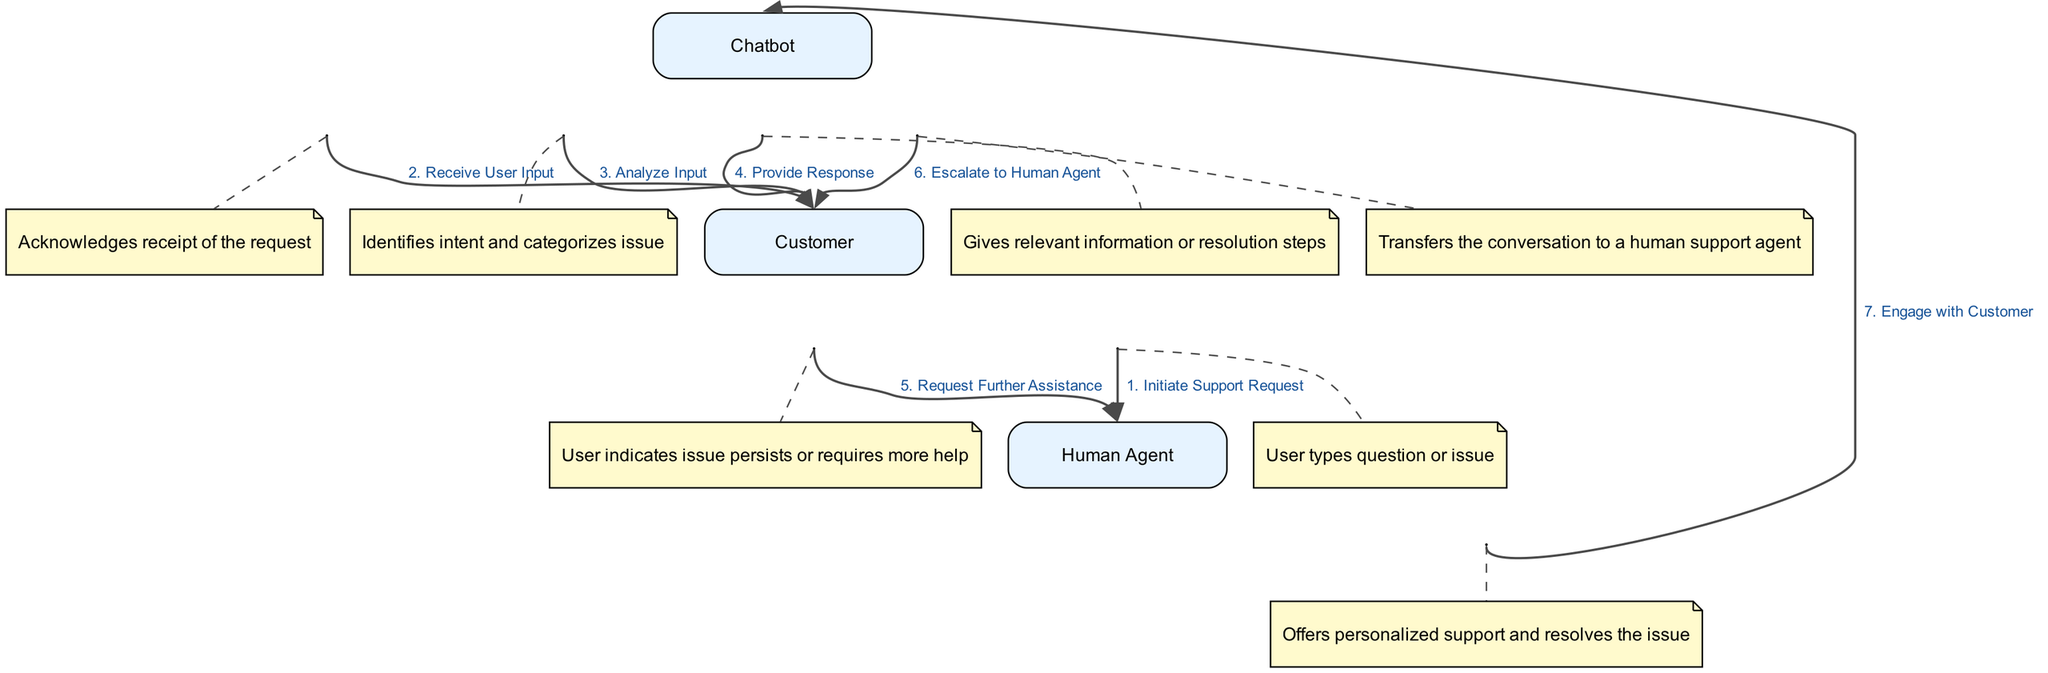What is the first action taken by the Customer? The diagram indicates that the first action taken by the Customer is to "Initiate Support Request." This is the very first element in the sequence outlining the process.
Answer: Initiate Support Request How many entities are represented in the diagram? There are three distinct entities in the diagram represented: Customer, Chatbot, and Human Agent. Each entity is shown as a separate box corresponding to their roles in the sequence.
Answer: Three What does the Chatbot do after receiving user input? After receiving the user input, the Chatbot performs the action "Analyze Input," which involves identifying the intent and categorizing the issue before providing a response.
Answer: Analyze Input What action occurs before escalating to a Human Agent? Before escalating to a Human Agent, the Customer must "Request Further Assistance," indicating that the issue is still unresolved or requires more help from the Chatbot. This action triggers the escalation process.
Answer: Request Further Assistance What is the last interaction in the sequence diagram? The last interaction in the sequence diagram occurs when the Human Agent "Engage with Customer," providing personalized support to resolve the issue. This is the concluding step in the narrative of the diagram.
Answer: Engage with Customer What type of edge connects the Chatbot to the Human Agent? The edge that connects the Chatbot to the Human Agent represents an escalation action, indicating that the conversation is transferred from the Chatbot to a Human Agent when the Customer needs further assistance.
Answer: Escalation edge Which entity acknowledges receipt of the support request? The entity that acknowledges the receipt of the support request is the Chatbot as it is the first response after the Customer initiates the support request.
Answer: Chatbot How many actions are performed by the Chatbot in the diagram? The Chatbot performs four distinct actions in the sequence: Receive User Input, Analyze Input, Provide Response, and Escalate to Human Agent. Counting these actions demonstrates its active role in the process.
Answer: Four 